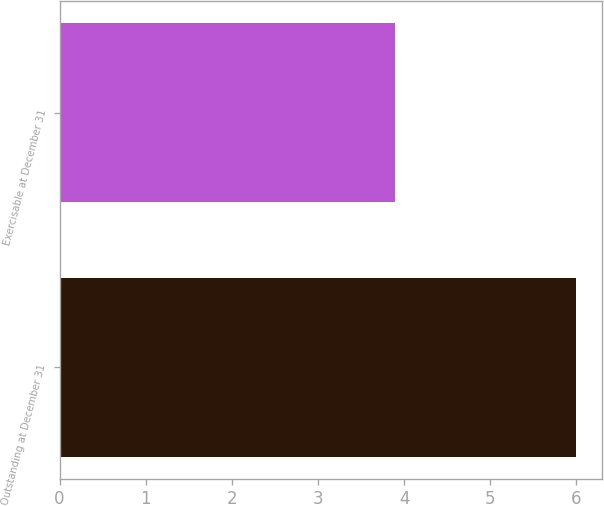Convert chart to OTSL. <chart><loc_0><loc_0><loc_500><loc_500><bar_chart><fcel>Outstanding at December 31<fcel>Exercisable at December 31<nl><fcel>6<fcel>3.9<nl></chart> 